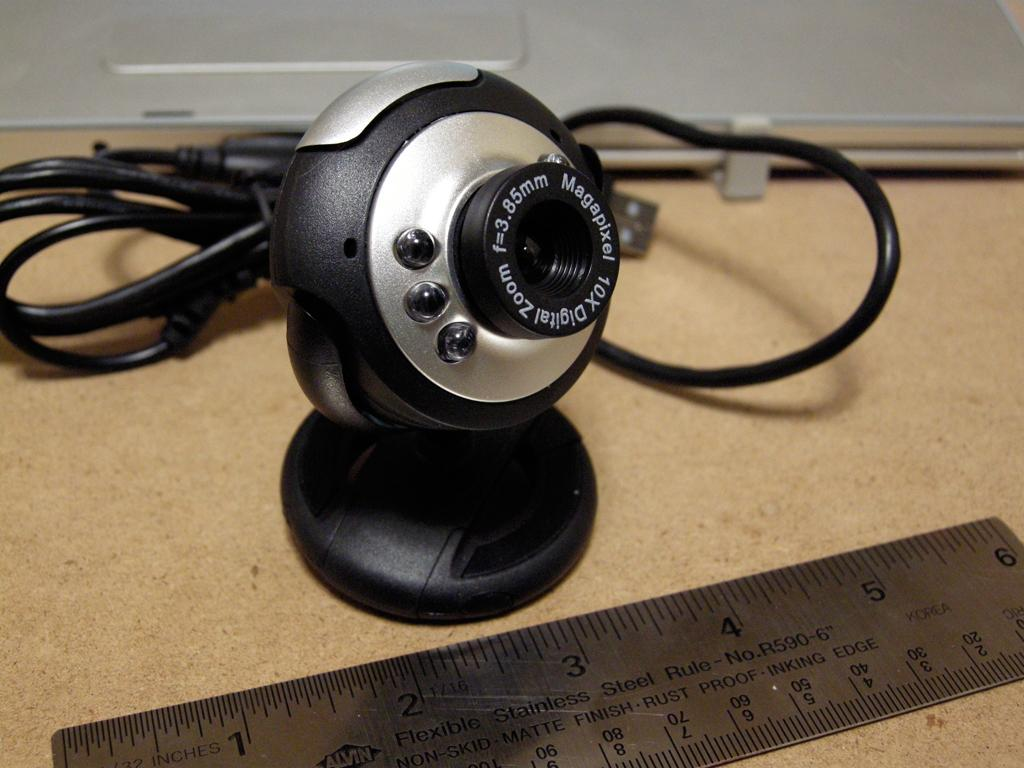<image>
Relay a brief, clear account of the picture shown. A web camera that says 10x zoom on sitting by a ruler. 